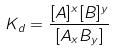Convert formula to latex. <formula><loc_0><loc_0><loc_500><loc_500>K _ { d } = \frac { [ A ] ^ { x } [ B ] ^ { y } } { [ A _ { x } B _ { y } ] }</formula> 